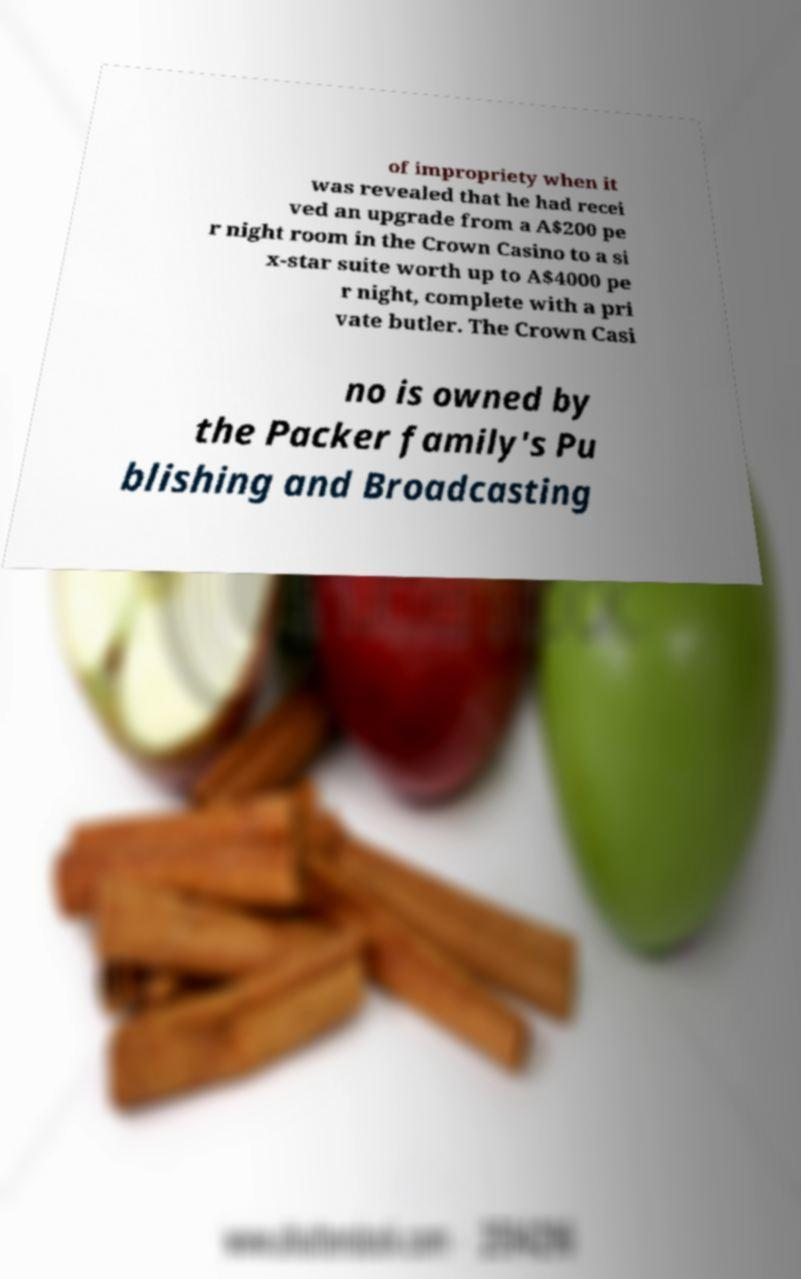Can you accurately transcribe the text from the provided image for me? of impropriety when it was revealed that he had recei ved an upgrade from a A$200 pe r night room in the Crown Casino to a si x-star suite worth up to A$4000 pe r night, complete with a pri vate butler. The Crown Casi no is owned by the Packer family's Pu blishing and Broadcasting 